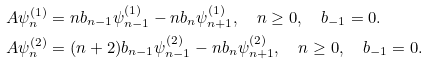Convert formula to latex. <formula><loc_0><loc_0><loc_500><loc_500>A { \psi _ { n } ^ { ( 1 ) } } & = n { b _ { n - 1 } } { \psi _ { n - 1 } ^ { ( 1 ) } } - n { b _ { n } } { \psi _ { n + 1 } ^ { ( 1 ) } } , \quad n \geq 0 , \quad b _ { - 1 } = 0 . \\ A { \psi _ { n } ^ { ( 2 ) } } & = ( n + 2 ) { b _ { n - 1 } } { \psi _ { n - 1 } ^ { ( 2 ) } } - n { b _ { n } } { \psi _ { n + 1 } ^ { ( 2 ) } } , \quad n \geq 0 , \quad b _ { - 1 } = 0 .</formula> 